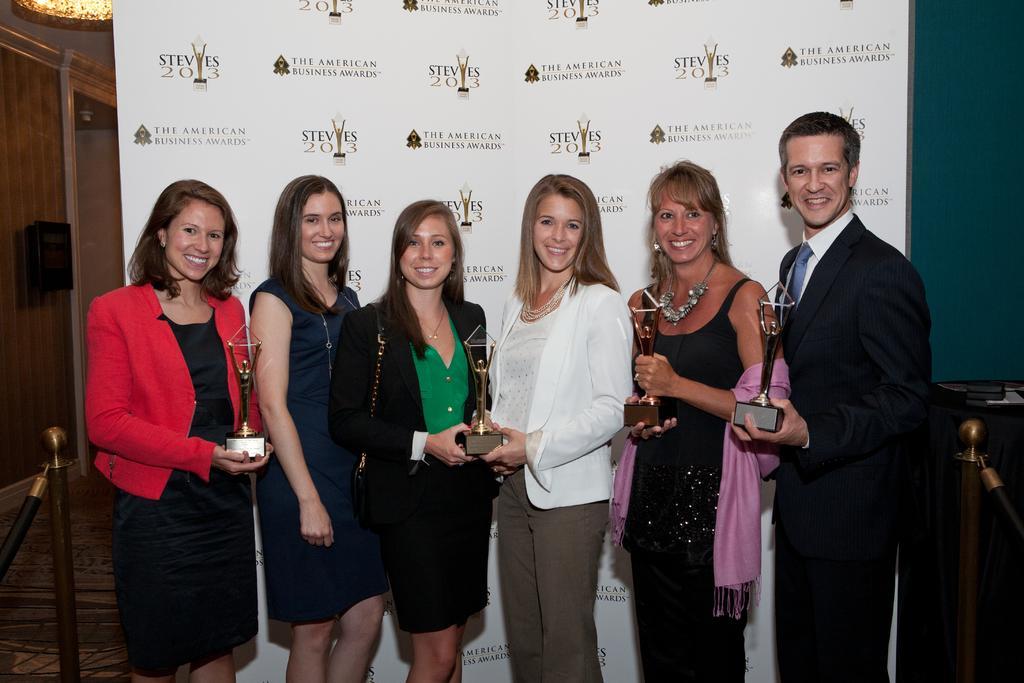In one or two sentences, can you explain what this image depicts? In this picture I can observe some people standing on the floor. Most of them are women. One of them is a man. Behind them I can observe a flex. All of them are smiling. 